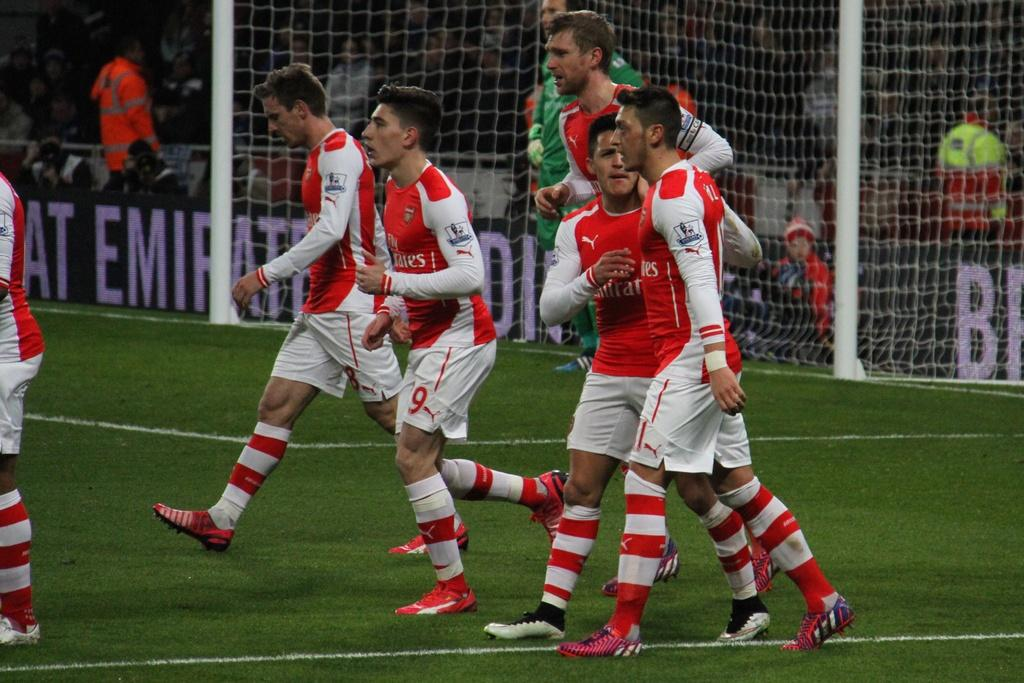<image>
Share a concise interpretation of the image provided. the number 9 is on the shorts of a person 